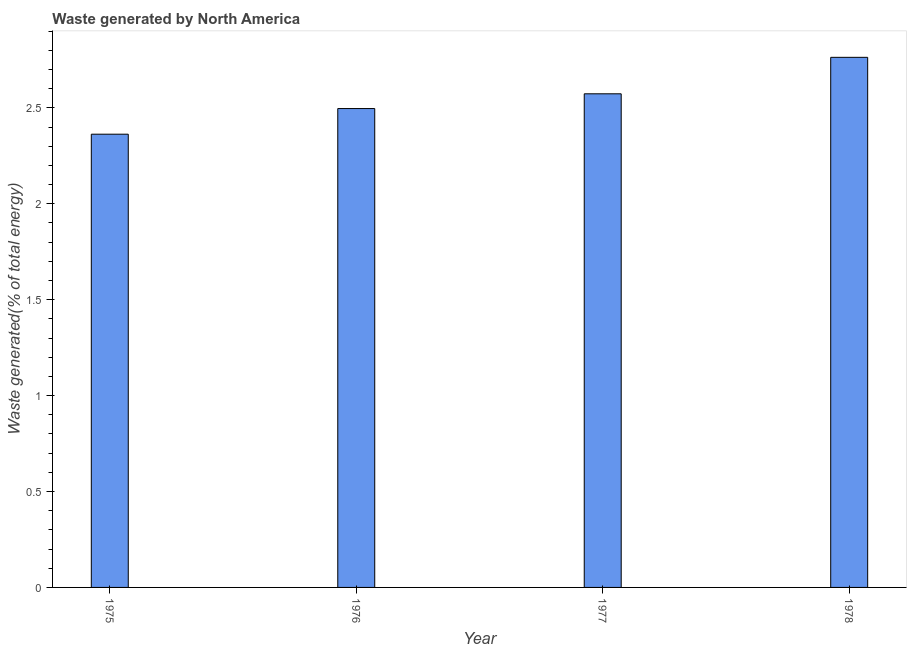Does the graph contain any zero values?
Give a very brief answer. No. Does the graph contain grids?
Give a very brief answer. No. What is the title of the graph?
Keep it short and to the point. Waste generated by North America. What is the label or title of the X-axis?
Make the answer very short. Year. What is the label or title of the Y-axis?
Your answer should be very brief. Waste generated(% of total energy). What is the amount of waste generated in 1975?
Provide a succinct answer. 2.36. Across all years, what is the maximum amount of waste generated?
Provide a short and direct response. 2.76. Across all years, what is the minimum amount of waste generated?
Make the answer very short. 2.36. In which year was the amount of waste generated maximum?
Provide a short and direct response. 1978. In which year was the amount of waste generated minimum?
Your response must be concise. 1975. What is the sum of the amount of waste generated?
Ensure brevity in your answer.  10.19. What is the difference between the amount of waste generated in 1975 and 1976?
Offer a very short reply. -0.13. What is the average amount of waste generated per year?
Your answer should be very brief. 2.55. What is the median amount of waste generated?
Provide a short and direct response. 2.53. In how many years, is the amount of waste generated greater than 2.2 %?
Your response must be concise. 4. What is the difference between the highest and the second highest amount of waste generated?
Your response must be concise. 0.19. In how many years, is the amount of waste generated greater than the average amount of waste generated taken over all years?
Provide a short and direct response. 2. Are all the bars in the graph horizontal?
Your response must be concise. No. How many years are there in the graph?
Offer a terse response. 4. What is the difference between two consecutive major ticks on the Y-axis?
Your response must be concise. 0.5. Are the values on the major ticks of Y-axis written in scientific E-notation?
Make the answer very short. No. What is the Waste generated(% of total energy) of 1975?
Offer a terse response. 2.36. What is the Waste generated(% of total energy) in 1976?
Make the answer very short. 2.5. What is the Waste generated(% of total energy) in 1977?
Provide a succinct answer. 2.57. What is the Waste generated(% of total energy) of 1978?
Your answer should be very brief. 2.76. What is the difference between the Waste generated(% of total energy) in 1975 and 1976?
Your response must be concise. -0.13. What is the difference between the Waste generated(% of total energy) in 1975 and 1977?
Provide a short and direct response. -0.21. What is the difference between the Waste generated(% of total energy) in 1975 and 1978?
Ensure brevity in your answer.  -0.4. What is the difference between the Waste generated(% of total energy) in 1976 and 1977?
Make the answer very short. -0.08. What is the difference between the Waste generated(% of total energy) in 1976 and 1978?
Offer a very short reply. -0.27. What is the difference between the Waste generated(% of total energy) in 1977 and 1978?
Your answer should be very brief. -0.19. What is the ratio of the Waste generated(% of total energy) in 1975 to that in 1976?
Provide a short and direct response. 0.95. What is the ratio of the Waste generated(% of total energy) in 1975 to that in 1977?
Make the answer very short. 0.92. What is the ratio of the Waste generated(% of total energy) in 1975 to that in 1978?
Your response must be concise. 0.85. What is the ratio of the Waste generated(% of total energy) in 1976 to that in 1978?
Your response must be concise. 0.9. 